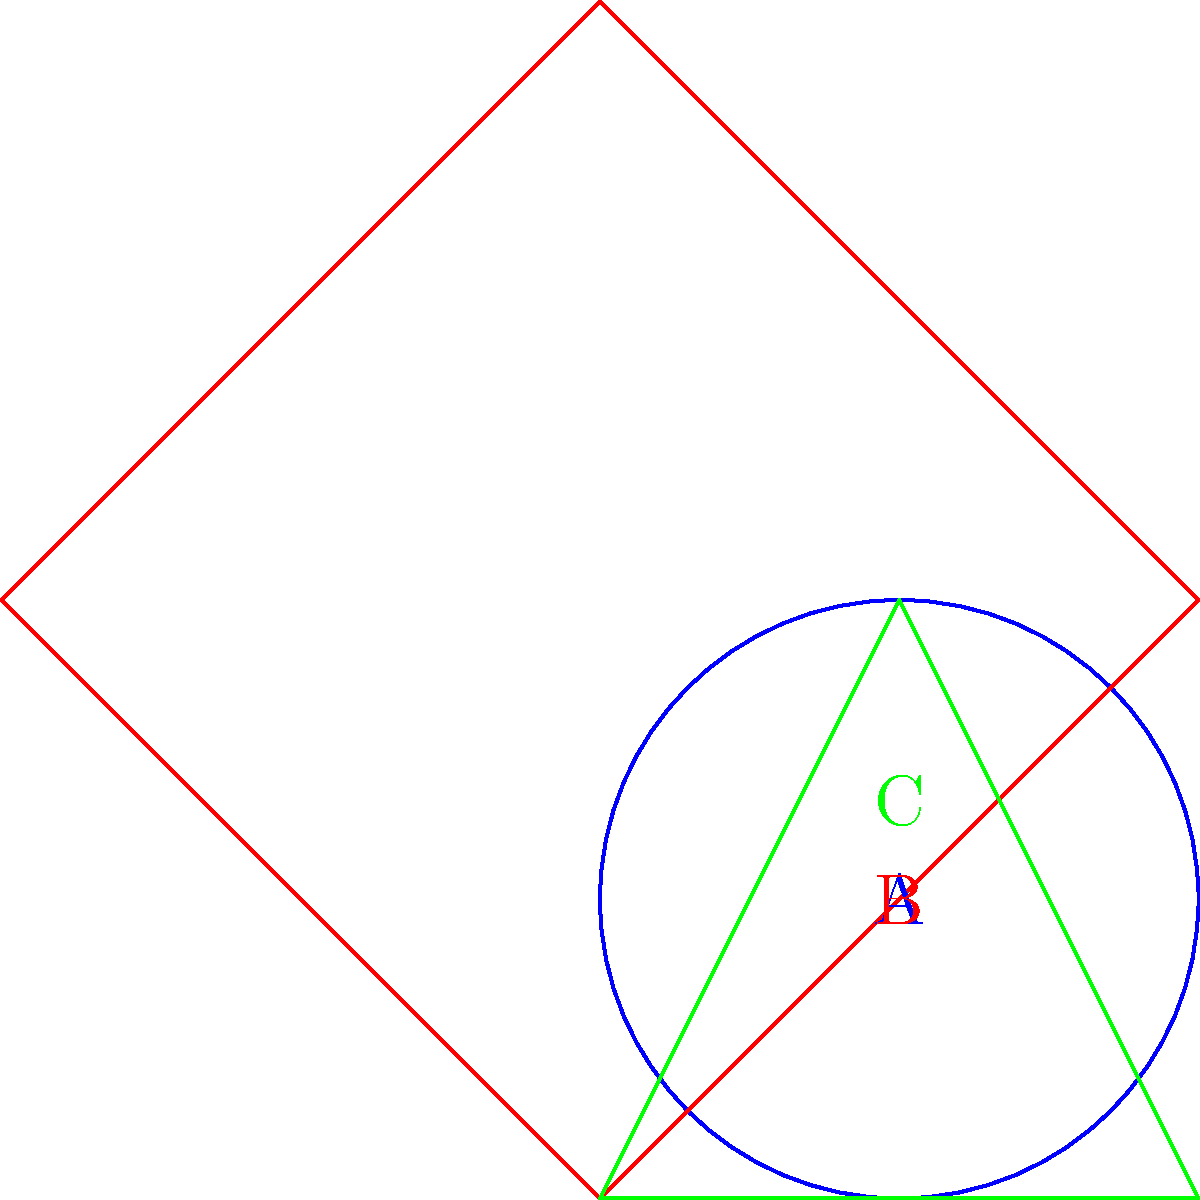In the diagram above, three different game objects are represented: a circle (A), a square (B), and a triangle (C). Which collision detection method would be most efficient for checking collisions between these objects in a 2D game environment? To determine the most efficient collision detection method for these objects, let's consider the properties of each shape and common collision detection techniques:

1. Circle (A):
   - Circles have a uniform shape defined by a center point and radius.
   - Collision detection for circles is typically done using distance calculations.

2. Square (B):
   - Squares have axis-aligned edges and corners.
   - They can be efficiently represented using Axis-Aligned Bounding Boxes (AABB).

3. Triangle (C):
   - Triangles have irregular shapes with three vertices.
   - They require more complex collision detection methods.

Given these characteristics, the most efficient collision detection method for all three shapes would be to use a hybrid approach:

1. Start with a broad-phase collision detection using Axis-Aligned Bounding Boxes (AABB) for all objects. This quickly eliminates pairs of objects that cannot possibly be colliding.

2. For objects that pass the AABB test, use shape-specific narrow-phase collision detection:
   - For circle-circle collisions: Use distance calculations between centers.
   - For circle-square or circle-triangle collisions: Use point-in-circle tests for vertices and closest point on edge calculations.
   - For square-square collisions: Continue using AABB tests.
   - For square-triangle or triangle-triangle collisions: Use the Separating Axis Theorem (SAT).

This hybrid approach combines the efficiency of AABB for broad-phase detection with shape-specific optimizations for narrow-phase detection, providing a good balance between performance and accuracy for these diverse shapes.
Answer: Hybrid AABB and shape-specific methods 